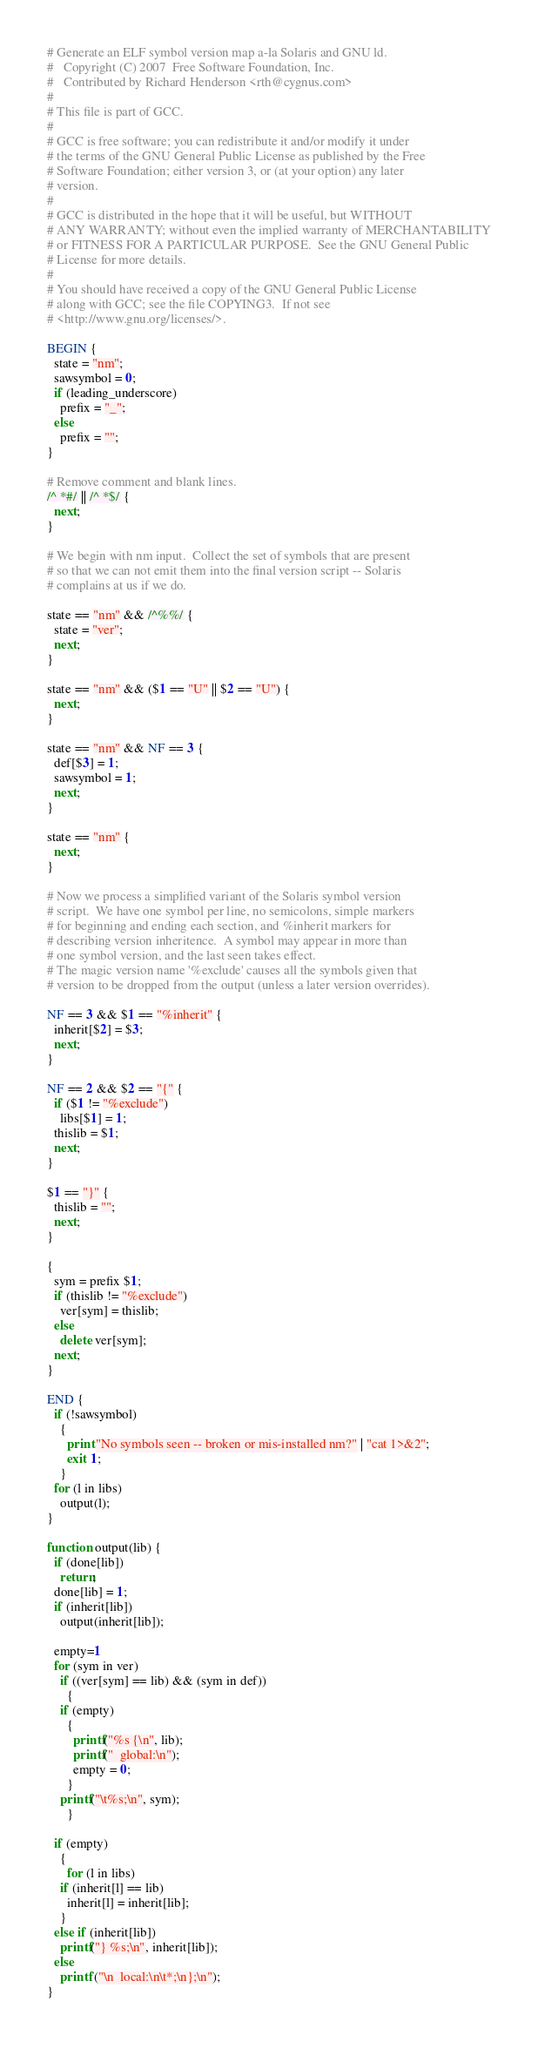Convert code to text. <code><loc_0><loc_0><loc_500><loc_500><_Awk_># Generate an ELF symbol version map a-la Solaris and GNU ld.
#	Copyright (C) 2007  Free Software Foundation, Inc.
#	Contributed by Richard Henderson <rth@cygnus.com>
#
# This file is part of GCC.
#
# GCC is free software; you can redistribute it and/or modify it under
# the terms of the GNU General Public License as published by the Free
# Software Foundation; either version 3, or (at your option) any later
# version.
#
# GCC is distributed in the hope that it will be useful, but WITHOUT
# ANY WARRANTY; without even the implied warranty of MERCHANTABILITY
# or FITNESS FOR A PARTICULAR PURPOSE.  See the GNU General Public
# License for more details.
#
# You should have received a copy of the GNU General Public License
# along with GCC; see the file COPYING3.  If not see
# <http://www.gnu.org/licenses/>.

BEGIN {
  state = "nm";
  sawsymbol = 0;
  if (leading_underscore)
    prefix = "_";
  else
    prefix = "";
}

# Remove comment and blank lines.
/^ *#/ || /^ *$/ {
  next;
}

# We begin with nm input.  Collect the set of symbols that are present
# so that we can not emit them into the final version script -- Solaris
# complains at us if we do.

state == "nm" && /^%%/ {
  state = "ver";
  next;
}

state == "nm" && ($1 == "U" || $2 == "U") {
  next;
}

state == "nm" && NF == 3 {
  def[$3] = 1;
  sawsymbol = 1;
  next;
}

state == "nm" {
  next;
}

# Now we process a simplified variant of the Solaris symbol version
# script.  We have one symbol per line, no semicolons, simple markers
# for beginning and ending each section, and %inherit markers for
# describing version inheritence.  A symbol may appear in more than
# one symbol version, and the last seen takes effect.
# The magic version name '%exclude' causes all the symbols given that
# version to be dropped from the output (unless a later version overrides).

NF == 3 && $1 == "%inherit" {
  inherit[$2] = $3;
  next;
}

NF == 2 && $2 == "{" {
  if ($1 != "%exclude")
    libs[$1] = 1;
  thislib = $1;
  next;
}

$1 == "}" {
  thislib = "";
  next;
}

{
  sym = prefix $1;
  if (thislib != "%exclude")
    ver[sym] = thislib;
  else
    delete ver[sym];
  next;
}

END {
  if (!sawsymbol)
    {
      print "No symbols seen -- broken or mis-installed nm?" | "cat 1>&2";
      exit 1;
    }
  for (l in libs)
    output(l);
}

function output(lib) {
  if (done[lib])
    return;
  done[lib] = 1;
  if (inherit[lib])
    output(inherit[lib]);

  empty=1
  for (sym in ver)
    if ((ver[sym] == lib) && (sym in def))
      {
	if (empty)
	  {
	    printf("%s {\n", lib);
	    printf("  global:\n");
	    empty = 0;
	  }
	printf("\t%s;\n", sym);
      }

  if (empty)
    {
      for (l in libs)
	if (inherit[l] == lib)
	  inherit[l] = inherit[lib];
    }
  else if (inherit[lib])
    printf("} %s;\n", inherit[lib]);
  else
    printf ("\n  local:\n\t*;\n};\n");
}
</code> 